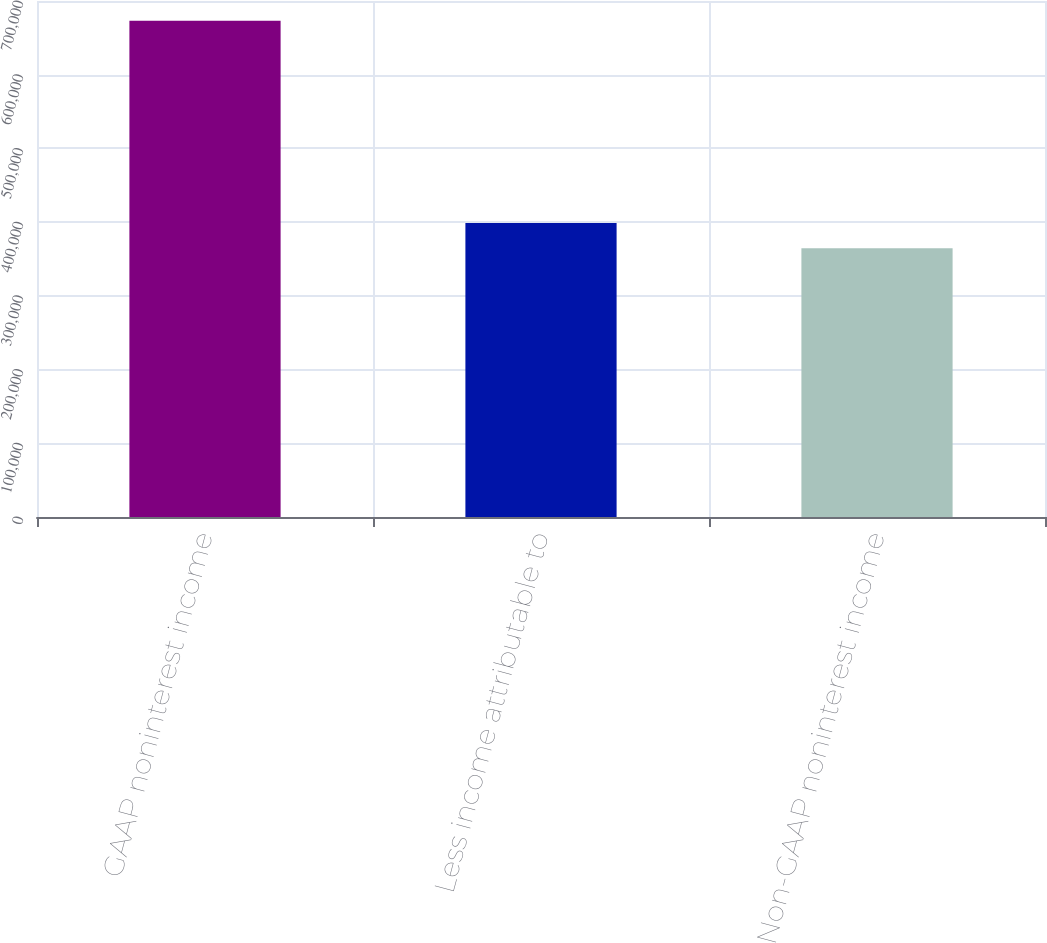Convert chart. <chart><loc_0><loc_0><loc_500><loc_500><bar_chart><fcel>GAAP noninterest income<fcel>Less income attributable to<fcel>Non-GAAP noninterest income<nl><fcel>673206<fcel>398883<fcel>364592<nl></chart> 